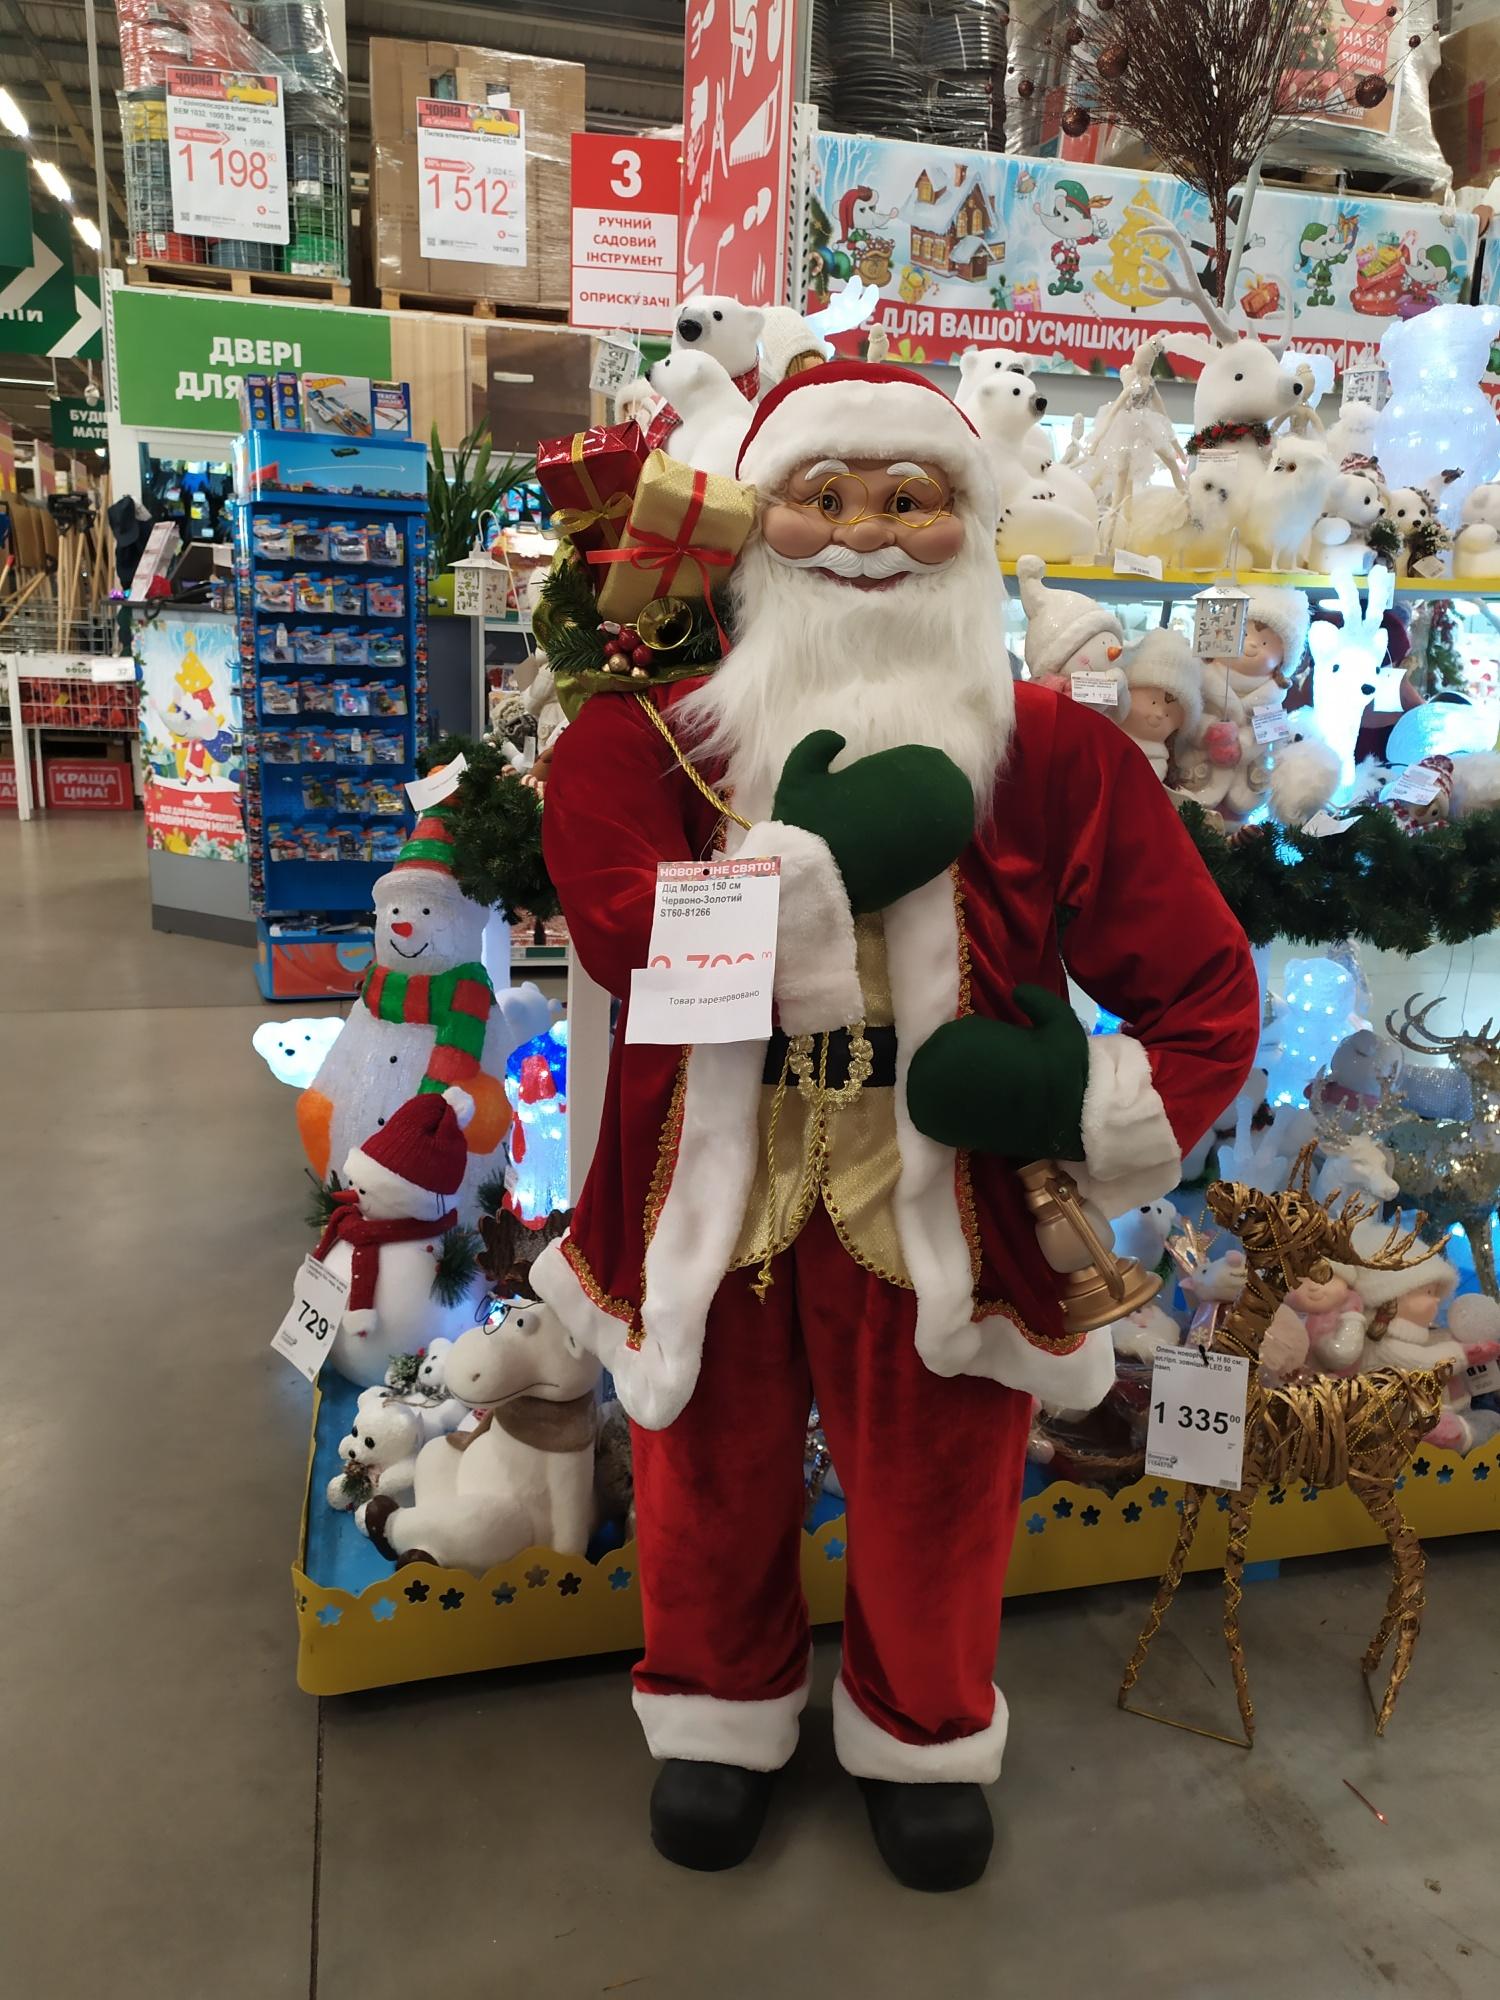Imagine an enchanting night scenario with the current setting in the image. Describe it vividly. On an enchanting night, the store transforms into a magical wonderland. The overhead lights dim, allowing the twinkling fairy lights and vibrant decorations to illuminate the space with a soft, radiant glow. Santa Claus, standing tall and merry, seems almost lifelike under the enchanting ambiance. The golden bell in his hand catches the gentle light, reflecting it in tiny sparkles across the room.

The stuffed animals and decorations, bathed in a mixture of warm and cool hues, create a mesmerizing backdrop. The reindeer figure glows softly with a golden shimmer, adding a touch of elegance and magic to the scene. The 'Новый год' banner, alight with twinkling lights, adds a festive sparkle that dances through the air.

Shoppers, drawn to the magical display, stroll leisurely, their faces lit with smiles and the joy of the season. The soft sound of holiday music plays in the background, enhancing the enchanting atmosphere. The whole scene feels like a wonderful, living Christmas card, captivating the heart and soul with its beauty and festive magic. 